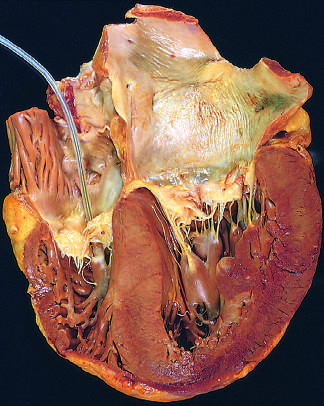s the atrium shown on the right in this four-chamber view of the heart?
Answer the question using a single word or phrase. Yes 